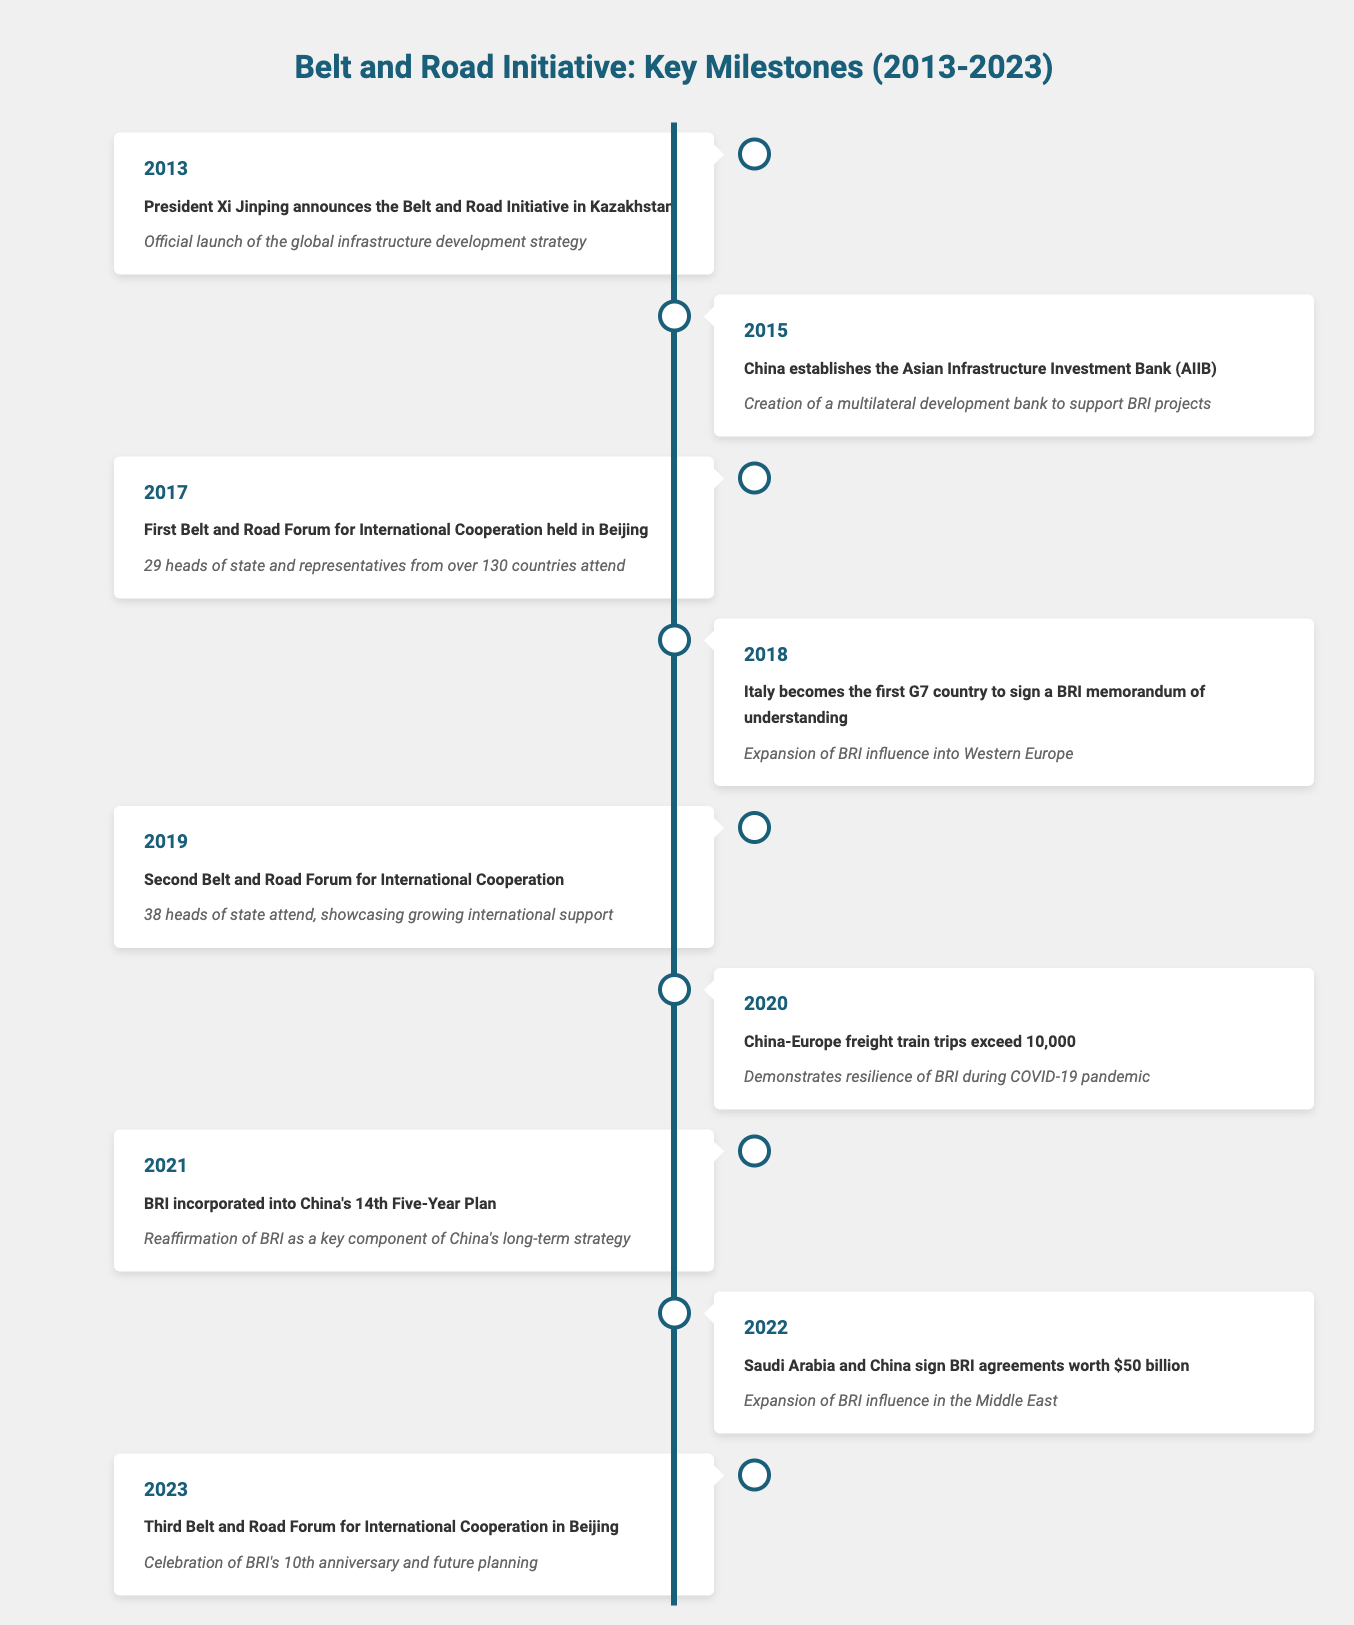What year was the Belt and Road Initiative officially launched? The table indicates that President Xi Jinping announced the Belt and Road Initiative in Kazakhstan in the year 2013, marking its official launch.
Answer: 2013 Which country was the first G7 nation to sign a BRI memorandum of understanding? According to the table, Italy became the first G7 country to sign a BRI memorandum of understanding in 2018.
Answer: Italy How many heads of state attended the first Belt and Road Forum for International Cooperation? The first Belt and Road Forum for International Cooperation, held in Beijing in 2017, recorded attendance from 29 heads of state as noted in the table.
Answer: 29 Was the Belt and Road Initiative included in China’s 14th Five-Year Plan? The table confirms that in 2021, BRI was incorporated into China's 14th Five-Year Plan, indicating a yes answer to the question.
Answer: Yes What is the significance of the Belt and Road agreements signed between Saudi Arabia and China in 2022? The table highlights that Saudi Arabia and China signed BRI agreements worth $50 billion in 2022, which signifies the expansion of BRI influence in the Middle East.
Answer: Expansion of BRI influence in the Middle East How many Belt and Road Forums for International Cooperation were held by 2023? By 2023, there were three Belt and Road Forums held: one in 2017, one in 2019, and one in 2023. Thus, summing these instances provides the total.
Answer: 3 What significant event occurred in 2020 related to BRI during the COVID-19 pandemic? In 2020, the table reveals that China-Europe freight train trips exceeded 10,000, showcasing the resilience of the BRI during the pandemic.
Answer: Exceeded 10,000 freight train trips Which milestone signifies the BRI's 10th anniversary? The third Belt and Road Forum for International Cooperation held in Beijing in 2023 celebrates BRI's 10th anniversary, as noted in the table.
Answer: Third Belt and Road Forum in 2023 How many years are there between the first and the second Belt and Road Forums for International Cooperation? The first forum was held in 2017 and the second in 2019. The difference in years is 2019 - 2017 = 2 years.
Answer: 2 years 